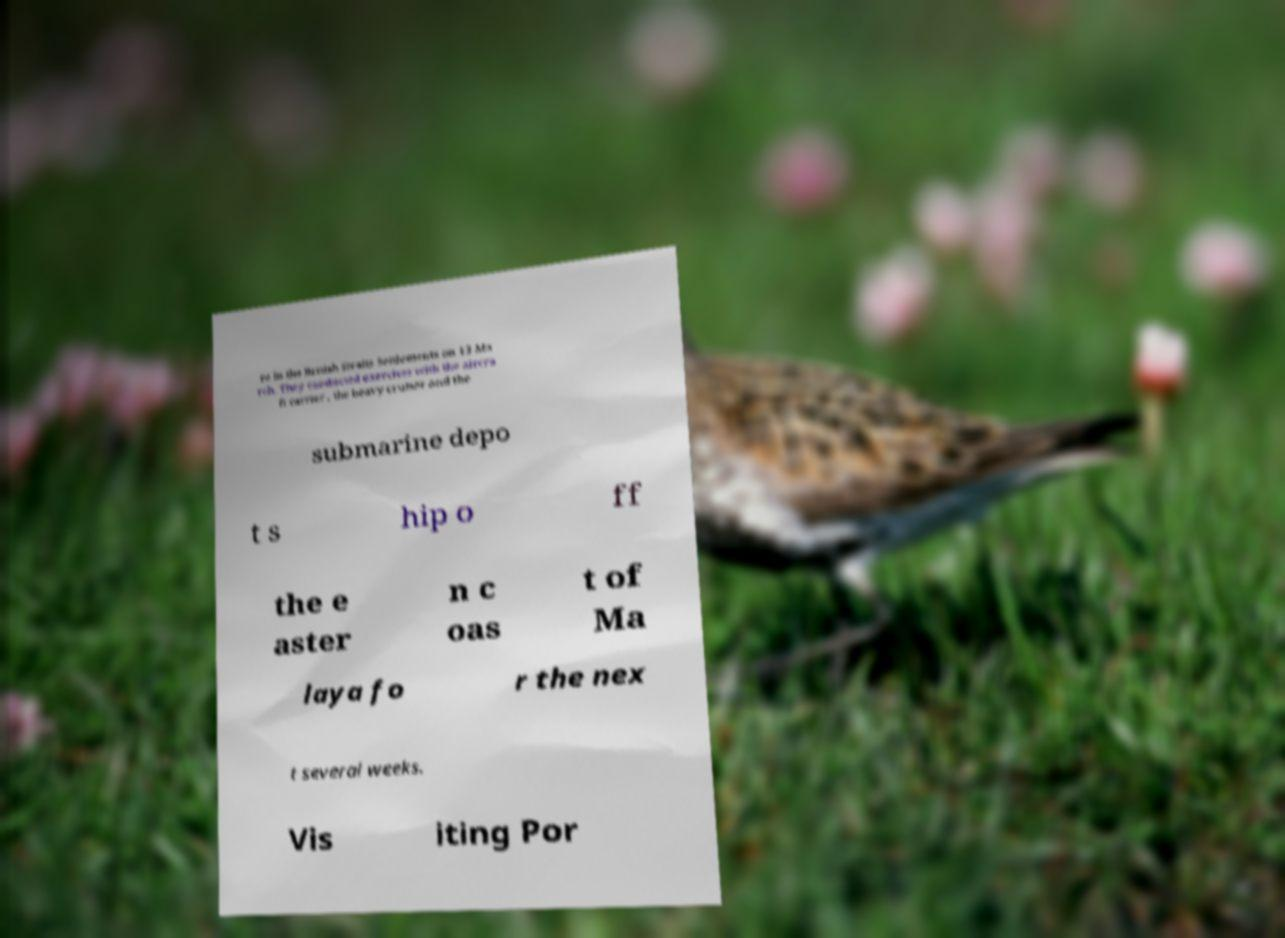There's text embedded in this image that I need extracted. Can you transcribe it verbatim? re in the British Straits Settlements on 13 Ma rch. They conducted exercises with the aircra ft carrier , the heavy cruiser and the submarine depo t s hip o ff the e aster n c oas t of Ma laya fo r the nex t several weeks. Vis iting Por 